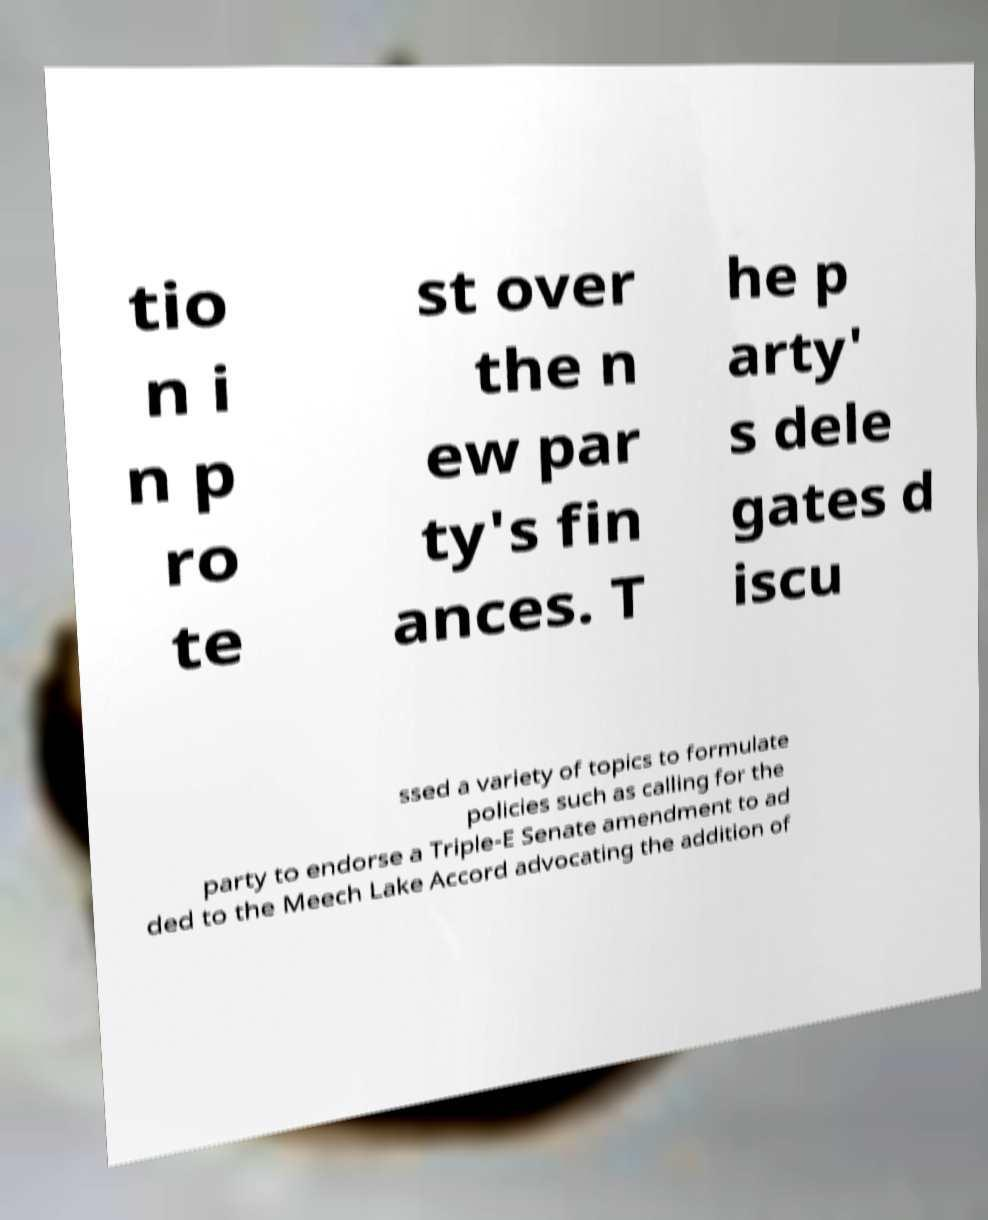Can you read and provide the text displayed in the image?This photo seems to have some interesting text. Can you extract and type it out for me? tio n i n p ro te st over the n ew par ty's fin ances. T he p arty' s dele gates d iscu ssed a variety of topics to formulate policies such as calling for the party to endorse a Triple-E Senate amendment to ad ded to the Meech Lake Accord advocating the addition of 